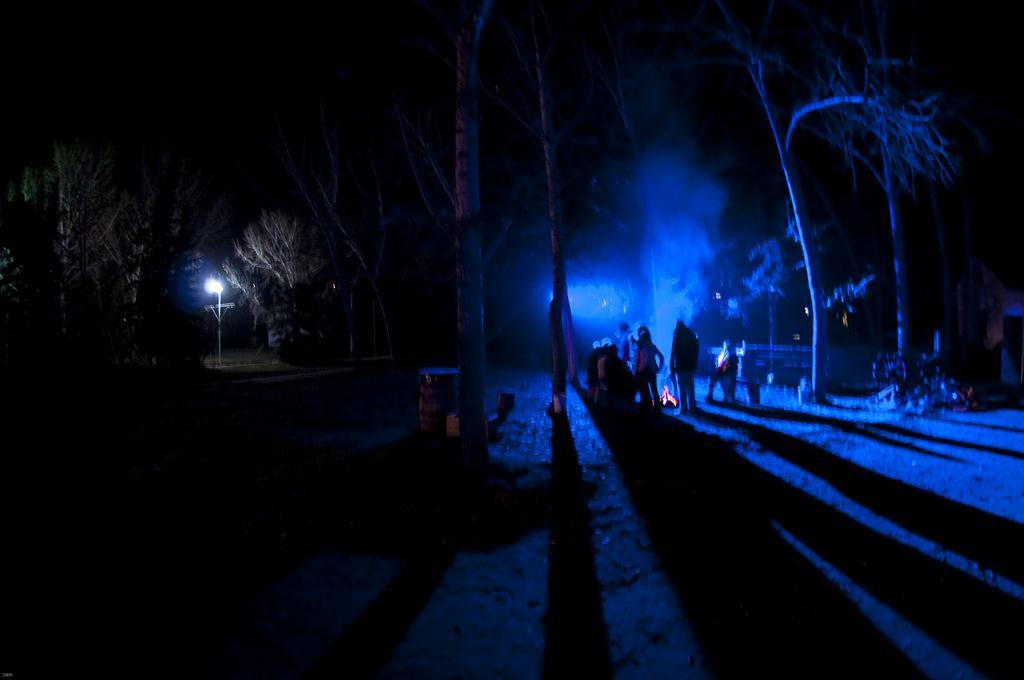Could you give a brief overview of what you see in this image? In this image there is a land at the bottom. In the middle there are few people standing on the ground around the camp fire. On the left side there is a pole to which there is a light. Beside the pool there are trees. This image is taken during the night time. 